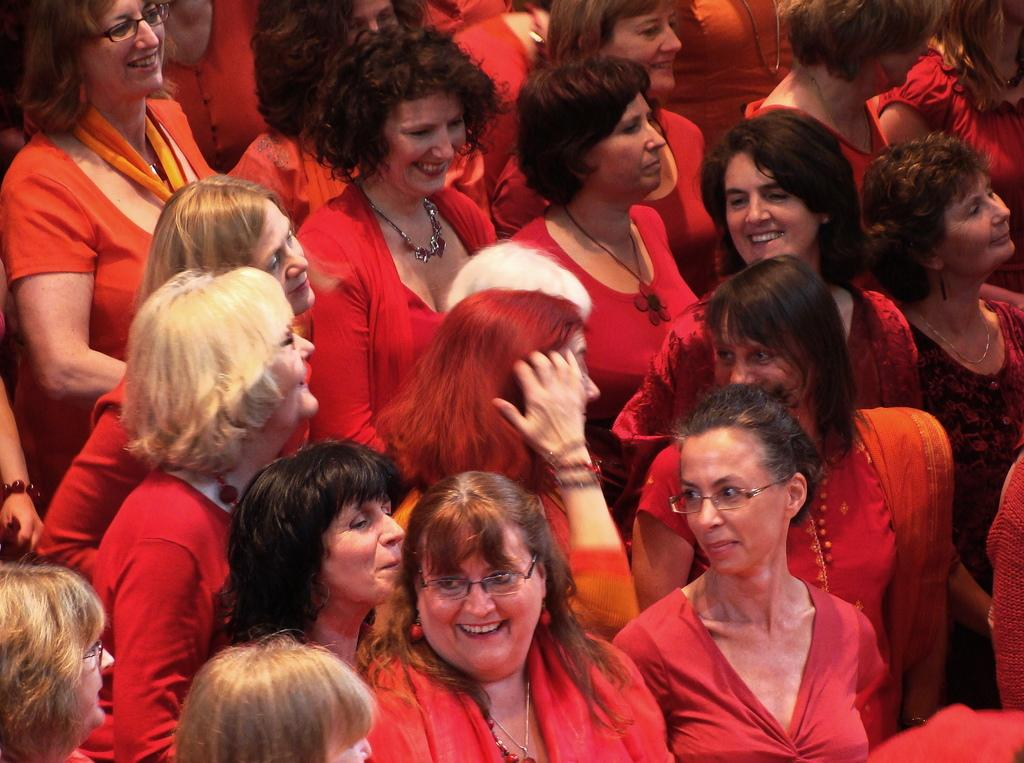What can be seen in the image? There is a group of women in the image. What are the women doing in the image? The women are standing and smiling. Can you describe any accessories the women are wearing? Some of the women are wearing spectacles. What type of balls can be seen on the desk in the image? There is no desk or balls present in the image; it features a group of women standing and smiling. 